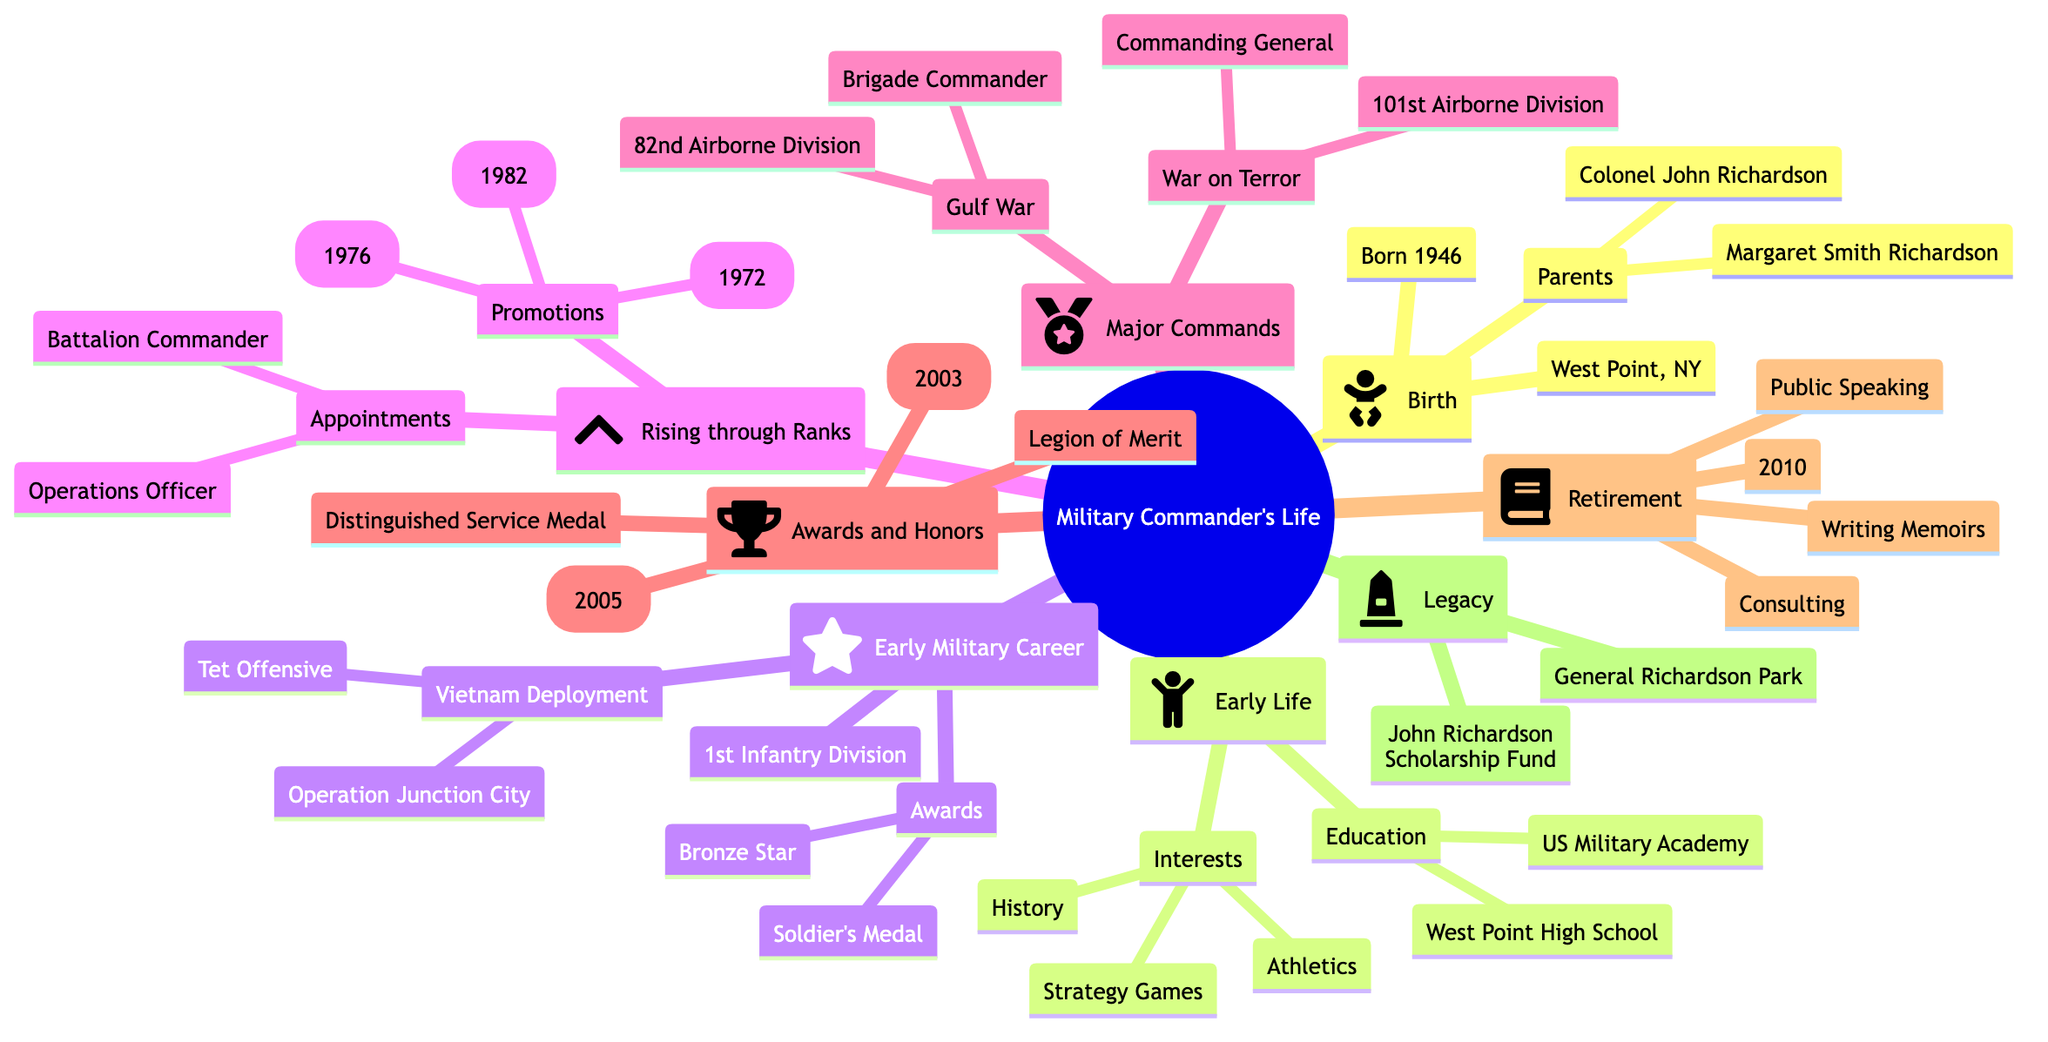What is the birth date of the military commander? The birth date is specified in the "Birth" section of the diagram. It states "1946-06-15" under that node.
Answer: 1946-06-15 Where did the military commander grow up? The diagram indicates that he was born in West Point, New York, under the "Birth" category, suggesting it is also his childhood place.
Answer: West Point, New York What was his first rank? Under "Early Military Career," the first assignment is as a "Platoon Leader" in the "1st Infantry Division." The rank held during this time is not explicitly stated, but it typically implies he was a Lieutenant upon initial assignment.
Answer: Lieutenant What major operation was he involved in during the Gulf War? The "Major Commands and Wars" section lists the operation he commanded as "Operation Desert Storm" under his role as Brigade Commander of the 82nd Airborne Division.
Answer: Operation Desert Storm How many medals are listed in the Awards section? In the "Awards and Honors" node, three specific medals are mentioned following the title "Medals." Counting them gives a total of three distinct medals.
Answer: 3 Which year did he retire? The "Retirement" section of the diagram states the retirement date as "2010-08-30," which can be interpreted as the year of retirement being 2010.
Answer: 2010 What is one notable work published after his retirement? The "Retirement" subsection lists "Book: Leading the Charge, Published: 2012," providing a clear indication of his notable work after leaving service.
Answer: Leading the Charge What role did he have in the War on Terror? The diagram states he served as the "Commanding General" of the 101st Airborne Division during the War on Terror. This specific link to his role is under the "War on Terror" node.
Answer: Commanding General How many significant appointments are recorded while he rose through the ranks? The "Rising through the Ranks" section enumerates two main significant appointments: "Battalion Commander" and "Operations Officer," resulting in a total count of two.
Answer: 2 